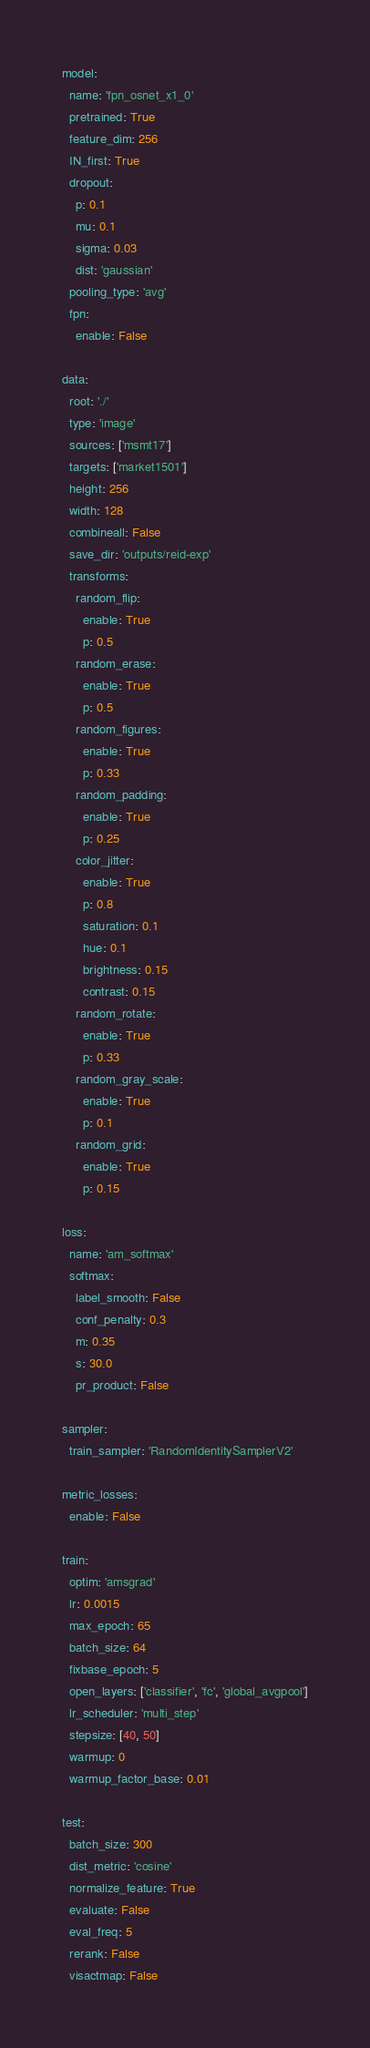<code> <loc_0><loc_0><loc_500><loc_500><_YAML_>model:
  name: 'fpn_osnet_x1_0'
  pretrained: True
  feature_dim: 256
  IN_first: True
  dropout:
    p: 0.1
    mu: 0.1
    sigma: 0.03
    dist: 'gaussian'
  pooling_type: 'avg'
  fpn:
    enable: False

data:
  root: './'
  type: 'image'
  sources: ['msmt17']
  targets: ['market1501']
  height: 256
  width: 128
  combineall: False
  save_dir: 'outputs/reid-exp'
  transforms:
    random_flip:
      enable: True
      p: 0.5
    random_erase:
      enable: True
      p: 0.5
    random_figures:
      enable: True
      p: 0.33
    random_padding:
      enable: True
      p: 0.25
    color_jitter:
      enable: True
      p: 0.8
      saturation: 0.1
      hue: 0.1
      brightness: 0.15
      contrast: 0.15
    random_rotate:
      enable: True
      p: 0.33
    random_gray_scale:
      enable: True
      p: 0.1
    random_grid:
      enable: True
      p: 0.15

loss:
  name: 'am_softmax'
  softmax:
    label_smooth: False
    conf_penalty: 0.3
    m: 0.35
    s: 30.0
    pr_product: False

sampler:
  train_sampler: 'RandomIdentitySamplerV2'

metric_losses:
  enable: False

train:
  optim: 'amsgrad'
  lr: 0.0015
  max_epoch: 65
  batch_size: 64
  fixbase_epoch: 5
  open_layers: ['classifier', 'fc', 'global_avgpool']
  lr_scheduler: 'multi_step'
  stepsize: [40, 50]
  warmup: 0
  warmup_factor_base: 0.01

test:
  batch_size: 300
  dist_metric: 'cosine'
  normalize_feature: True
  evaluate: False
  eval_freq: 5
  rerank: False
  visactmap: False
</code> 